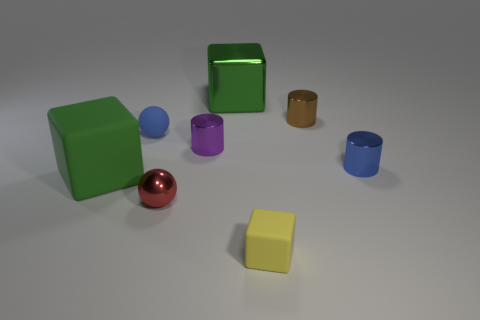What material is the small blue object that is the same shape as the purple thing?
Ensure brevity in your answer.  Metal. How many cubes are the same size as the green matte object?
Make the answer very short. 1. Do the metallic cube and the brown metal object have the same size?
Offer a terse response. No. How big is the block that is in front of the tiny blue matte sphere and behind the red metallic ball?
Make the answer very short. Large. Are there more tiny cylinders to the left of the large metal block than tiny objects that are to the right of the brown shiny object?
Your response must be concise. No. There is a big metal thing that is the same shape as the large matte thing; what color is it?
Provide a short and direct response. Green. There is a ball that is behind the red thing; is it the same color as the small cube?
Offer a terse response. No. What number of small red shiny objects are there?
Offer a terse response. 1. Does the large green cube on the left side of the tiny shiny ball have the same material as the brown cylinder?
Your answer should be compact. No. Are there any other things that have the same material as the tiny red sphere?
Make the answer very short. Yes. 